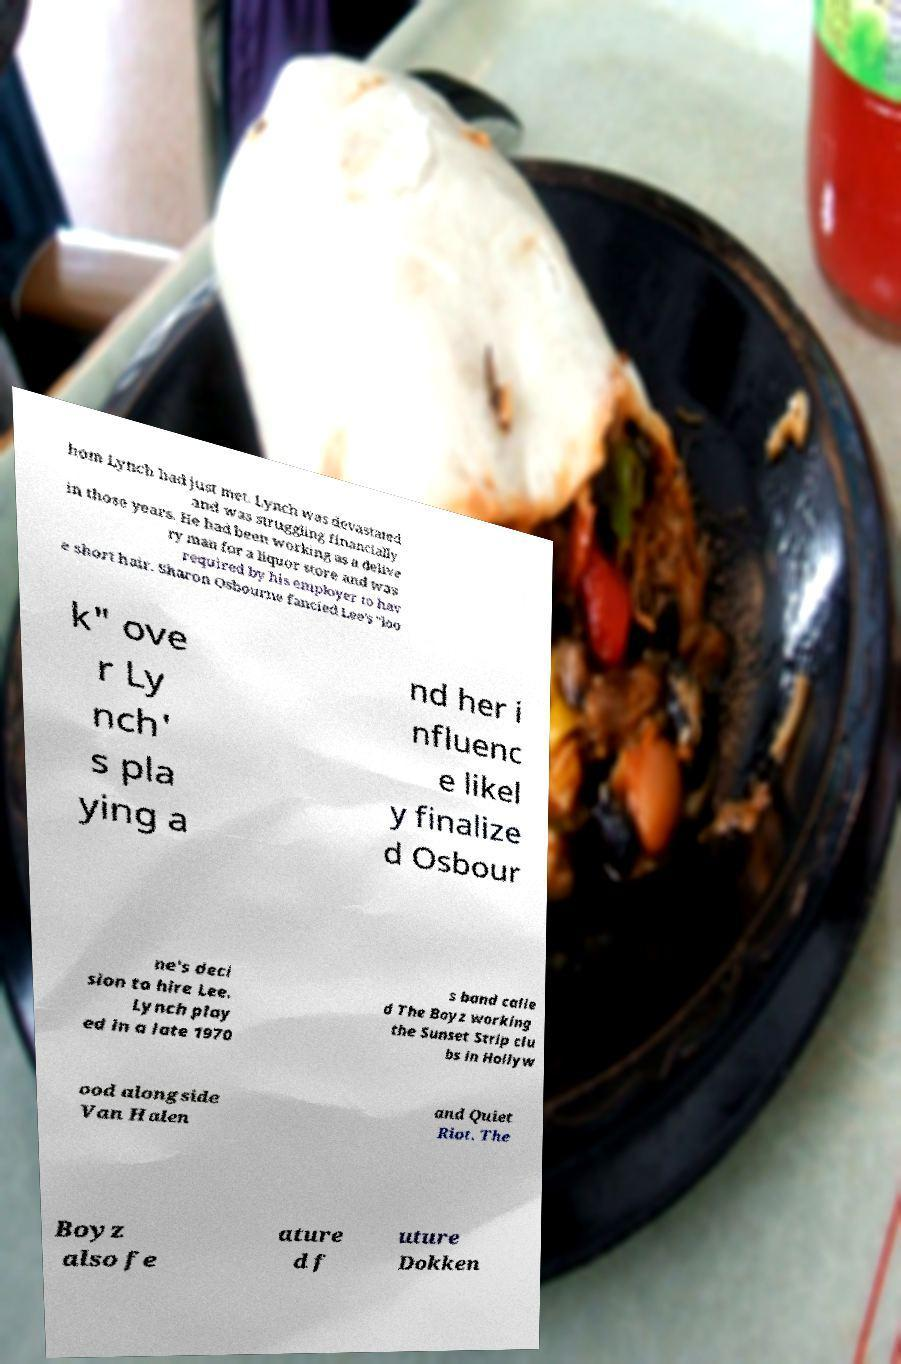Can you read and provide the text displayed in the image?This photo seems to have some interesting text. Can you extract and type it out for me? hom Lynch had just met. Lynch was devastated and was struggling financially in those years. He had been working as a delive ry man for a liquor store and was required by his employer to hav e short hair. Sharon Osbourne fancied Lee's "loo k" ove r Ly nch' s pla ying a nd her i nfluenc e likel y finalize d Osbour ne's deci sion to hire Lee. Lynch play ed in a late 1970 s band calle d The Boyz working the Sunset Strip clu bs in Hollyw ood alongside Van Halen and Quiet Riot. The Boyz also fe ature d f uture Dokken 